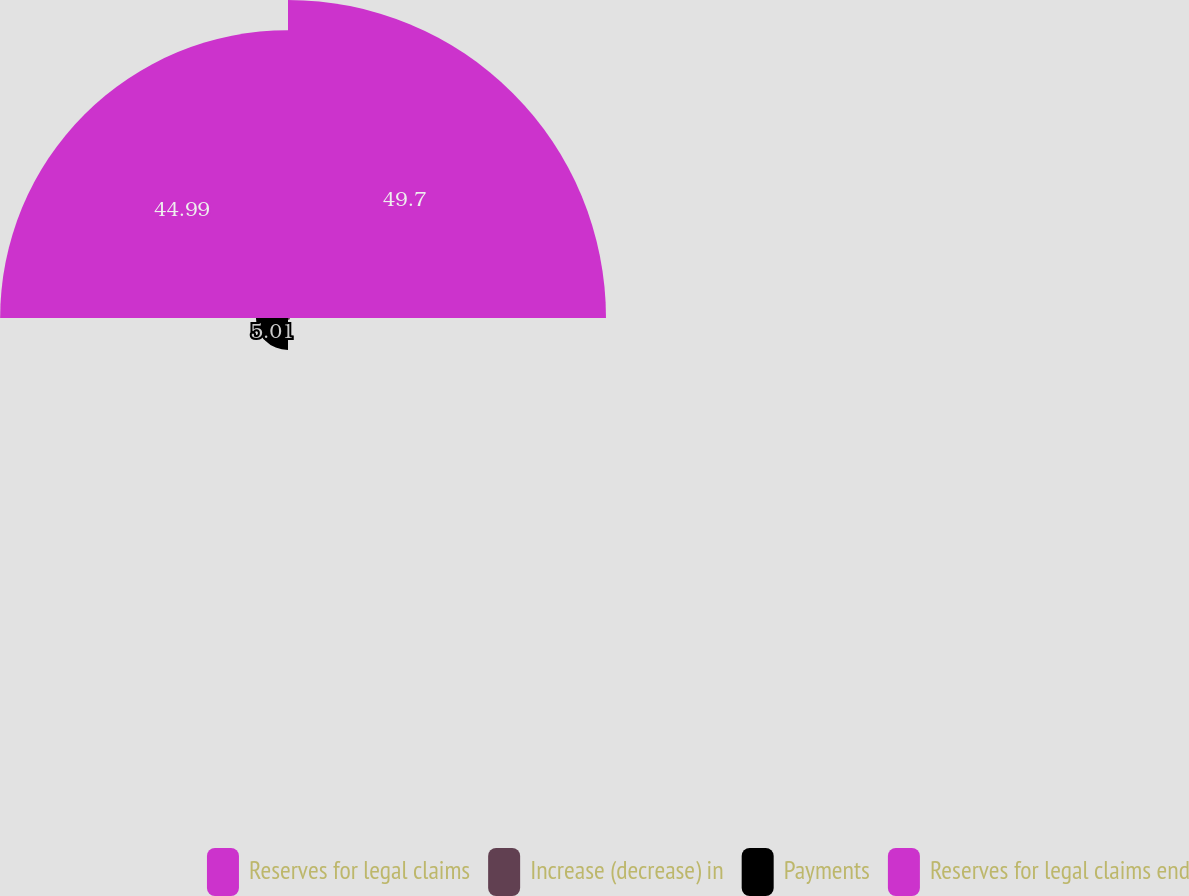Convert chart. <chart><loc_0><loc_0><loc_500><loc_500><pie_chart><fcel>Reserves for legal claims<fcel>Increase (decrease) in<fcel>Payments<fcel>Reserves for legal claims end<nl><fcel>49.7%<fcel>0.3%<fcel>5.01%<fcel>44.99%<nl></chart> 